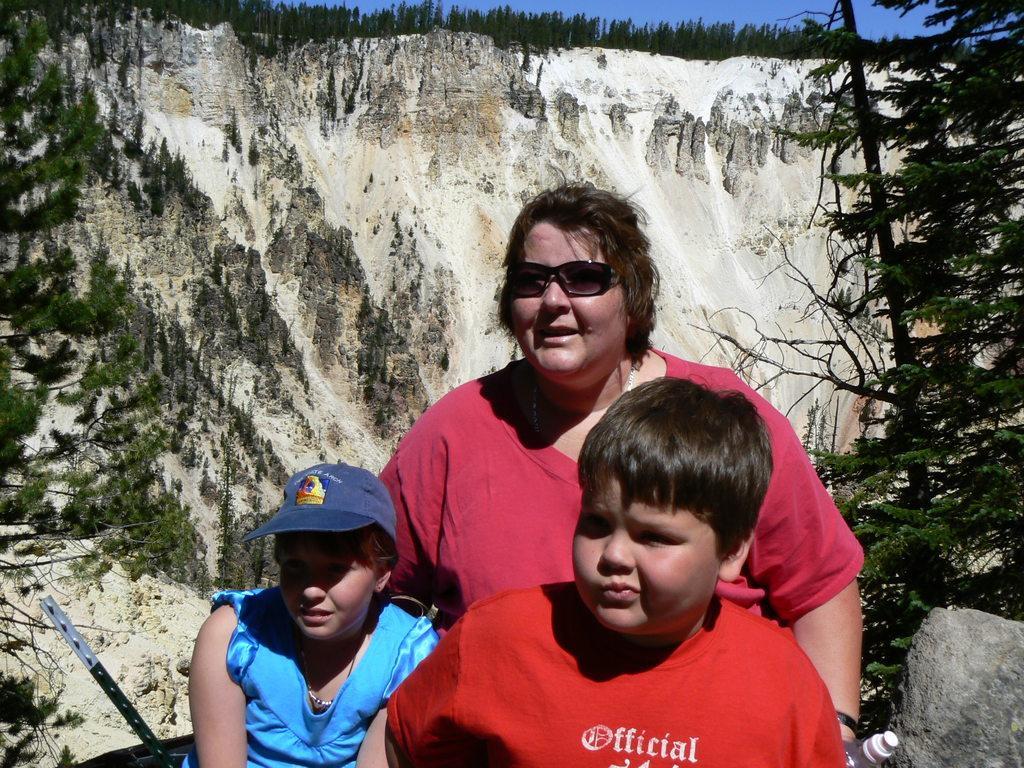How would you summarize this image in a sentence or two? In the image there is a boy. And also there is a girl with cap. Behind them there is a lady with goggles and she is holding something in the hand. In the background there is a hill. On the top of the image on the hill there are trees. And also there are trees in the image. 